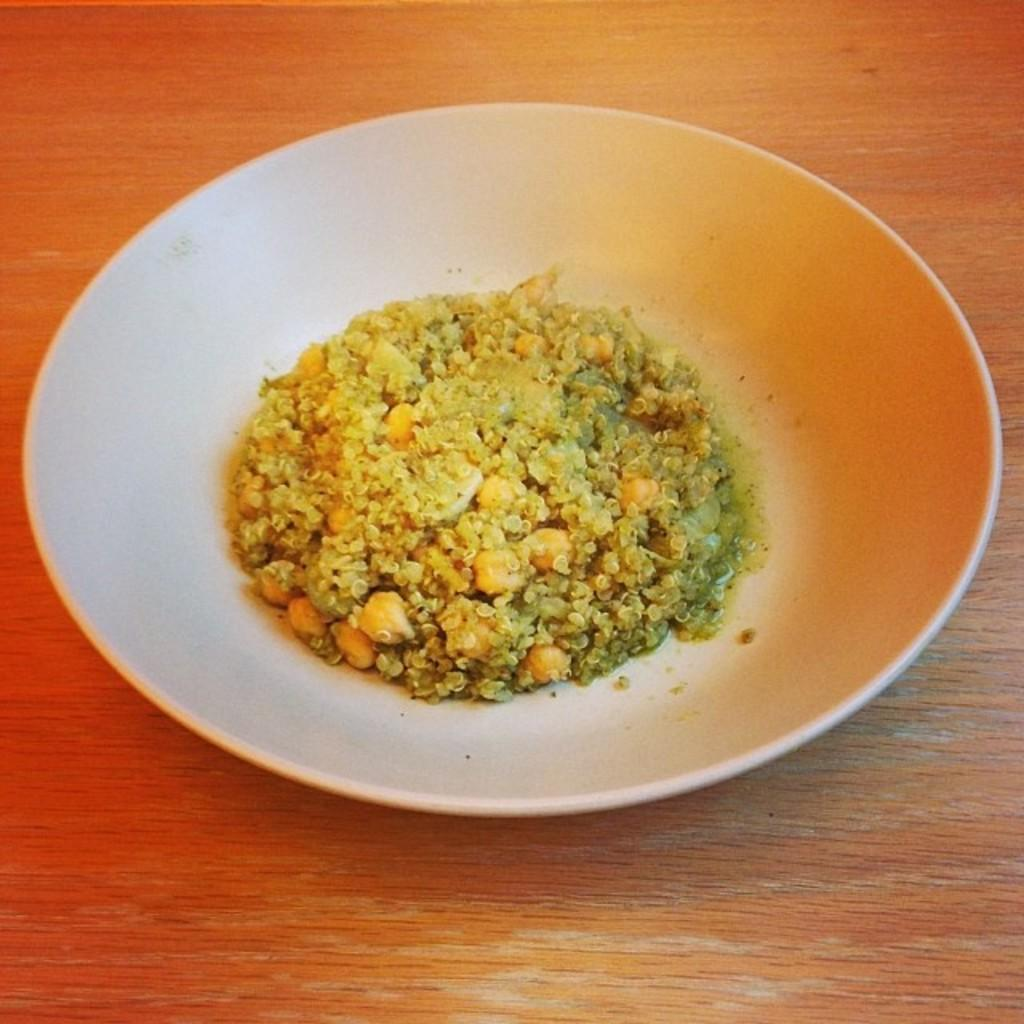What is located on the table in the image? There is a bowl on the table in the image. What is the purpose of the bowl in the image? The bowl contains food. What type of structure can be seen in the sky in the image? There is no structure visible in the sky in the image. Who is the creator of the food in the bowl in the image? The creator of the food in the bowl is not mentioned in the image. 